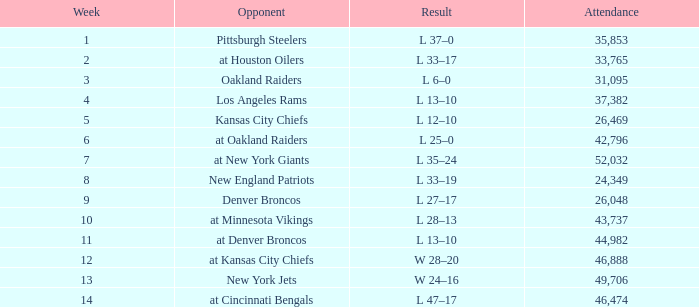What is the initial week when the result was 13-10, november 30, 1975, with an audience exceeding 44,982 individuals? None. 